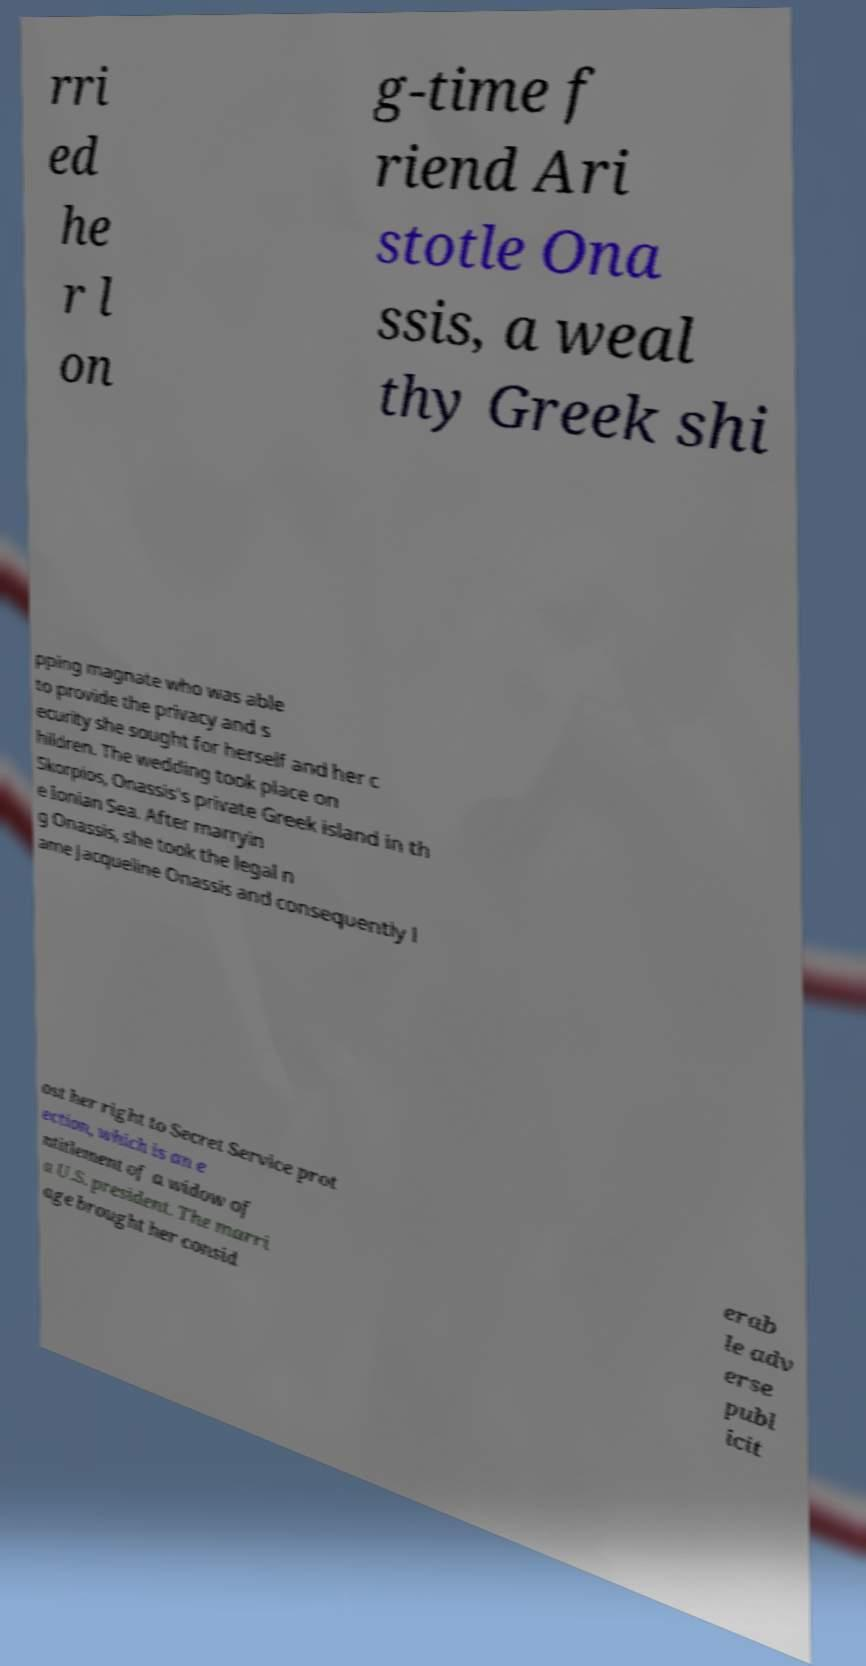Can you accurately transcribe the text from the provided image for me? rri ed he r l on g-time f riend Ari stotle Ona ssis, a weal thy Greek shi pping magnate who was able to provide the privacy and s ecurity she sought for herself and her c hildren. The wedding took place on Skorpios, Onassis's private Greek island in th e Ionian Sea. After marryin g Onassis, she took the legal n ame Jacqueline Onassis and consequently l ost her right to Secret Service prot ection, which is an e ntitlement of a widow of a U.S. president. The marri age brought her consid erab le adv erse publ icit 